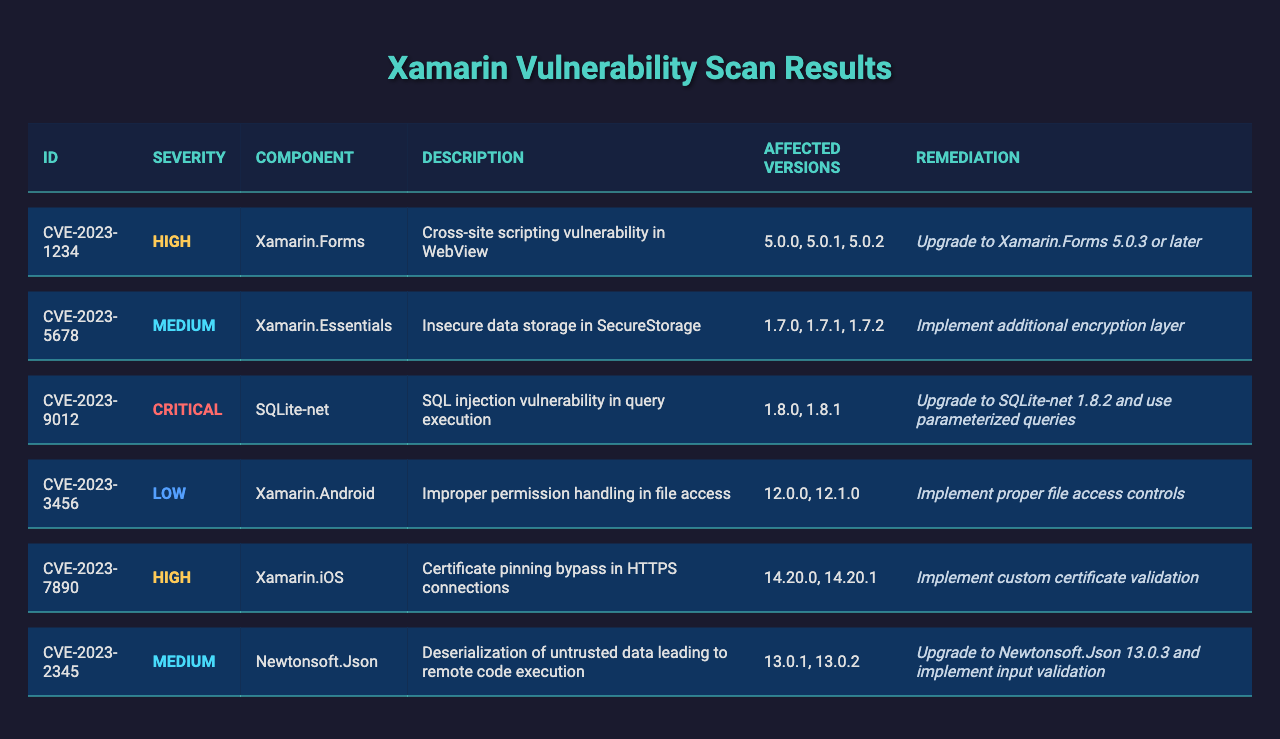What is the highest severity vulnerability listed in the table? The table indicates that "CVE-2023-9012" has a severity level marked as "Critical," which is the highest listed severity.
Answer: CVE-2023-9012 How many vulnerabilities are categorized as High severity? There are two vulnerabilities labeled as "High" severity: "CVE-2023-1234" and "CVE-2023-7890."
Answer: 2 Which component has a vulnerability related to SQL injection? The component "SQLite-net" has an associated vulnerability identified as "CVE-2023-9012," which describes a SQL injection issue.
Answer: SQLite-net What remediation is suggested for vulnerabilities in Xamarin.Forms? The vulnerability "CVE-2023-1234" indicates that upgrading to Xamarin.Forms version 5.0.3 or later is the suggested remediation action.
Answer: Upgrade to 5.0.3 or later Are there any vulnerabilities listed for Xamarin.Android? Yes, the table includes a vulnerability "CVE-2023-3456" that pertains to "Xamarin.Android."
Answer: Yes What is the remediation for the vulnerability affecting Xamarin.Essentials? The suggested remediation for "CVE-2023-5678," which affects Xamarin.Essentials, is to implement an additional encryption layer.
Answer: Implement additional encryption layer How many components have been identified with vulnerabilities? There are six unique components listed in the vulnerabilities: Xamarin.Forms, Xamarin.Essentials, SQLite-net, Xamarin.Android, Xamarin.iOS, and Newtonsoft.Json.
Answer: 6 What is the difference in severity between the highest and lowest severity vulnerabilities? The highest severity is "Critical" and the lowest is "Low." The difference in severity levels shows that "Critical" is two levels above "Low" on the severity scale.
Answer: 2 levels Which vulnerability requires the implementation of input validation as a remediation? The vulnerability identified as "CVE-2023-2345" mentions the need for input validation in its remediation steps.
Answer: CVE-2023-2345 Is there any vulnerability that affects both Xamarin.iOS and Xamarin.Android? No, the vulnerabilities affecting Xamarin.iOS and Xamarin.Android are separate and do not overlap.
Answer: No 